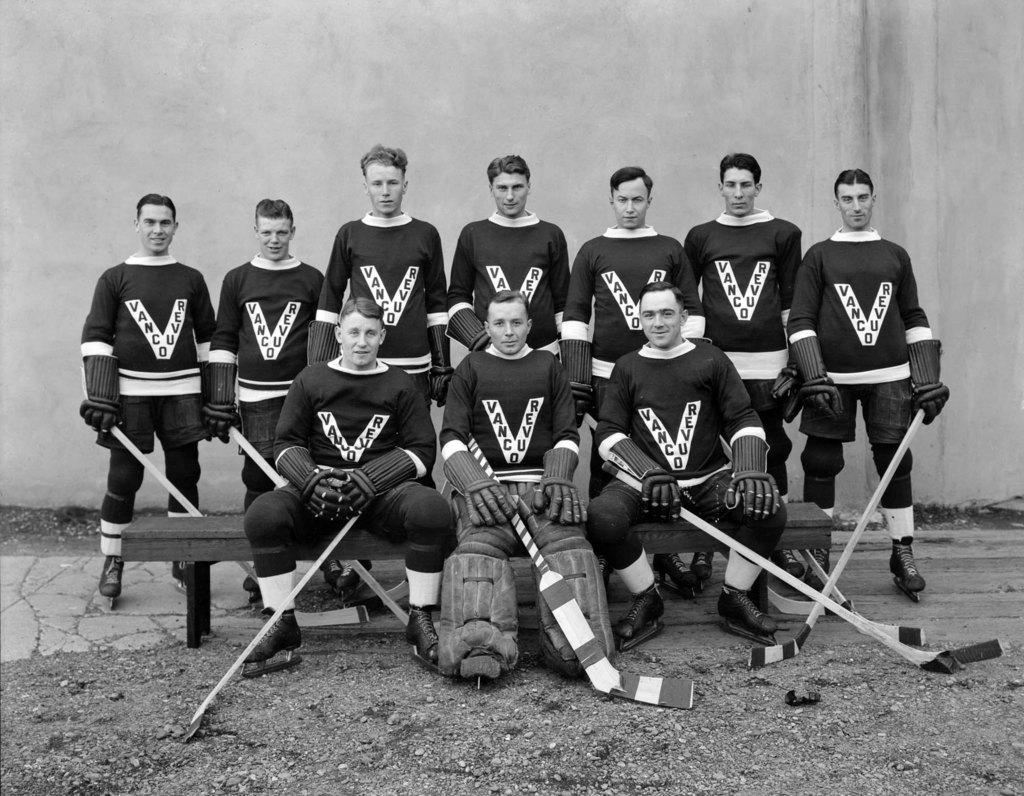<image>
Render a clear and concise summary of the photo. The Vancouver hockey goalie sits in the middle of his team mates, on the bench. 